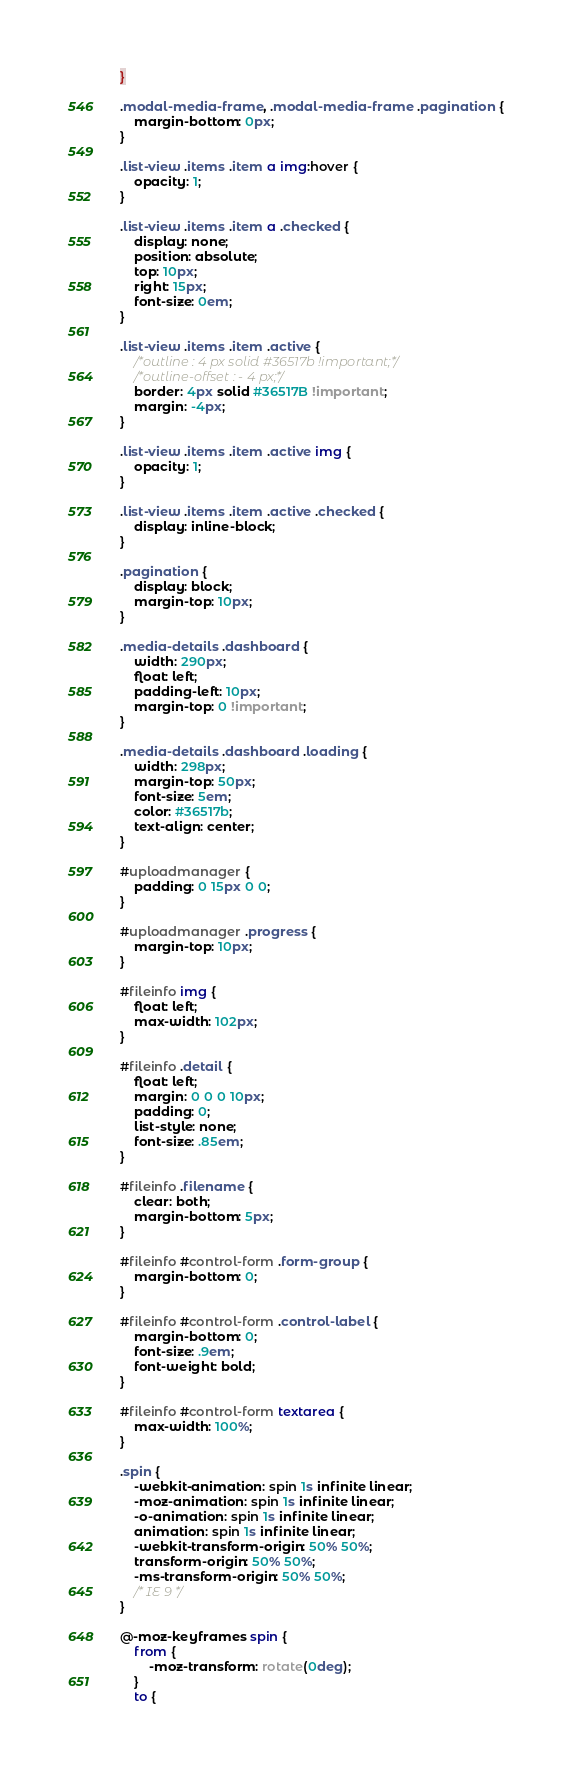<code> <loc_0><loc_0><loc_500><loc_500><_CSS_>}

.modal-media-frame, .modal-media-frame .pagination {
    margin-bottom: 0px;
}

.list-view .items .item a img:hover {
    opacity: 1;
}

.list-view .items .item a .checked {
    display: none;
    position: absolute;
    top: 10px;
    right: 15px;
    font-size: 0em;
}

.list-view .items .item .active {
    /*outline : 4 px solid #36517b !important;*/
    /*outline-offset : - 4 px;*/
    border: 4px solid #36517B !important;
    margin: -4px;
}

.list-view .items .item .active img {
    opacity: 1;
}

.list-view .items .item .active .checked {
    display: inline-block;
}

.pagination {
    display: block;
    margin-top: 10px;
}

.media-details .dashboard {
    width: 290px;
    float: left;
    padding-left: 10px;
    margin-top: 0 !important;
}

.media-details .dashboard .loading {
    width: 298px;
    margin-top: 50px;
    font-size: 5em;
    color: #36517b;
    text-align: center;
}

#uploadmanager {
    padding: 0 15px 0 0;
}

#uploadmanager .progress {
    margin-top: 10px;
}

#fileinfo img {
    float: left;
    max-width: 102px;
}

#fileinfo .detail {
    float: left;
    margin: 0 0 0 10px;
    padding: 0;
    list-style: none;
    font-size: .85em;
}

#fileinfo .filename {
    clear: both;
    margin-bottom: 5px;
}

#fileinfo #control-form .form-group {
    margin-bottom: 0;
}

#fileinfo #control-form .control-label {
    margin-bottom: 0;
    font-size: .9em;
    font-weight: bold;
}

#fileinfo #control-form textarea {
    max-width: 100%;
}

.spin {
    -webkit-animation: spin 1s infinite linear;
    -moz-animation: spin 1s infinite linear;
    -o-animation: spin 1s infinite linear;
    animation: spin 1s infinite linear;
    -webkit-transform-origin: 50% 50%;
    transform-origin: 50% 50%;
    -ms-transform-origin: 50% 50%;
    /* IE 9 */
}

@-moz-keyframes spin {
    from {
        -moz-transform: rotate(0deg);
    }
    to {</code> 